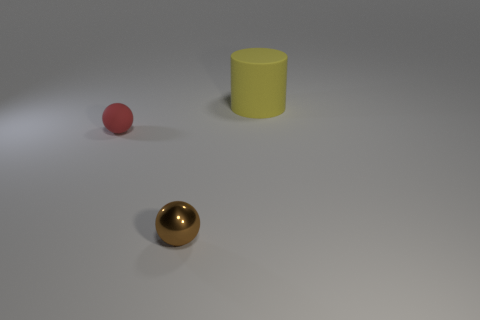Add 1 big objects. How many objects exist? 4 Subtract all brown balls. How many balls are left? 1 Subtract all small things. Subtract all tiny brown shiny spheres. How many objects are left? 0 Add 1 small balls. How many small balls are left? 3 Add 3 tiny brown spheres. How many tiny brown spheres exist? 4 Subtract 0 gray cylinders. How many objects are left? 3 Subtract all cylinders. How many objects are left? 2 Subtract all blue balls. Subtract all purple cubes. How many balls are left? 2 